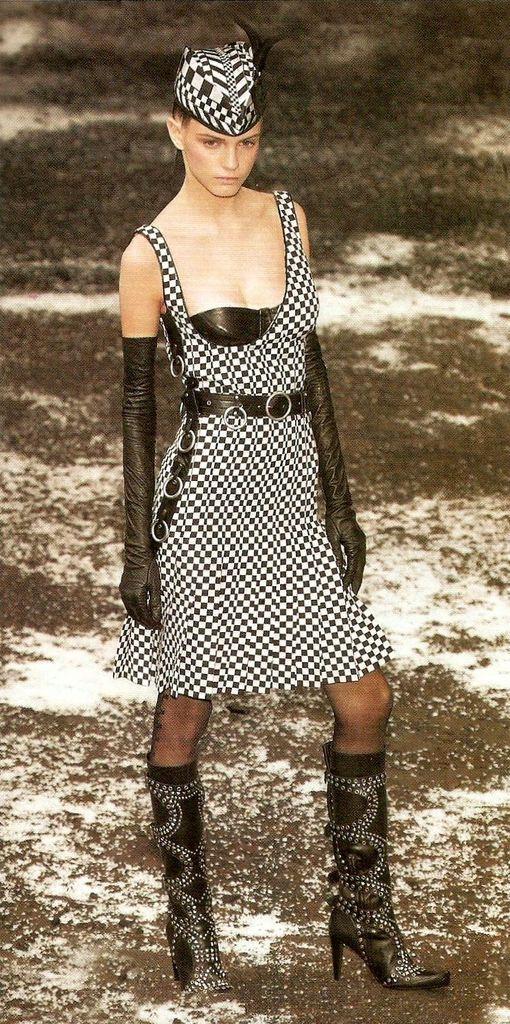In one or two sentences, can you explain what this image depicts? In this image we can see a woman standing and in the background we can see the land. 